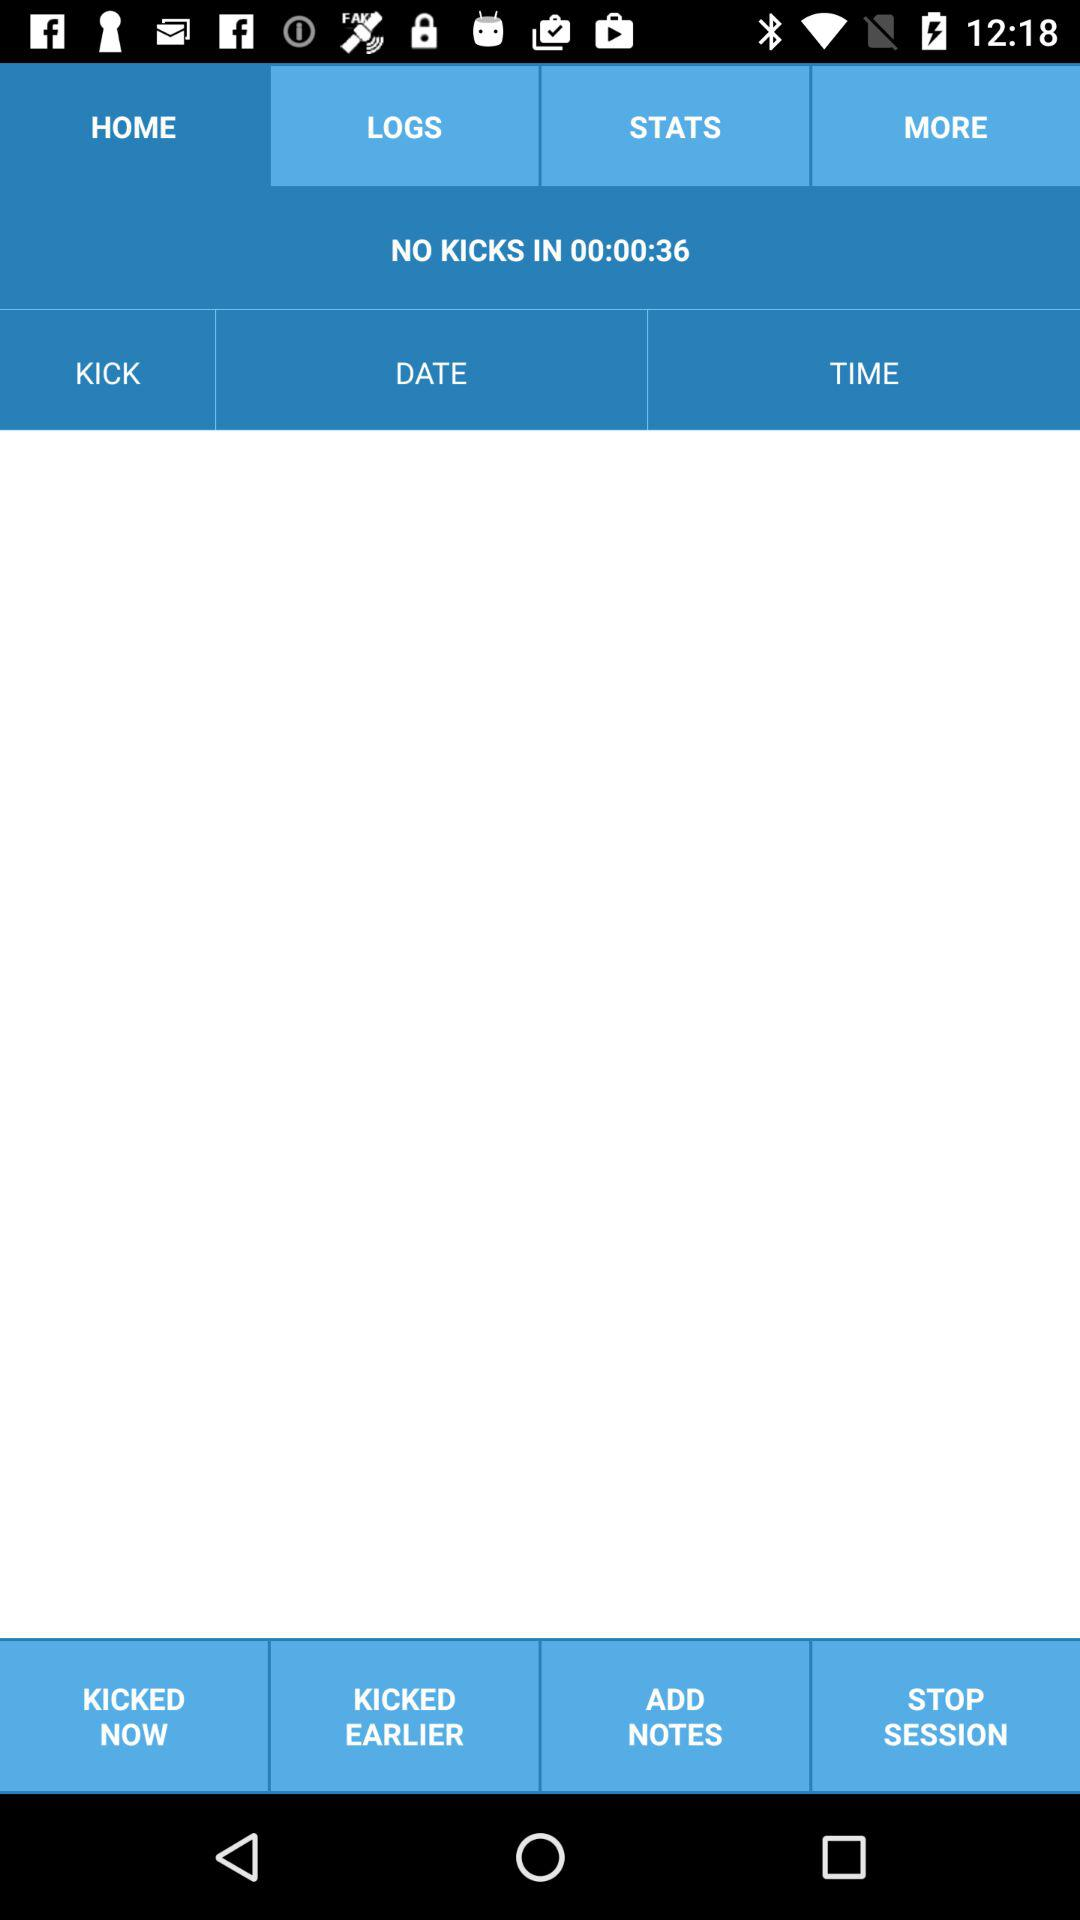Which tab is not selected? The tabs that are not selected are "LOGS", "STATS" and "MORE". 